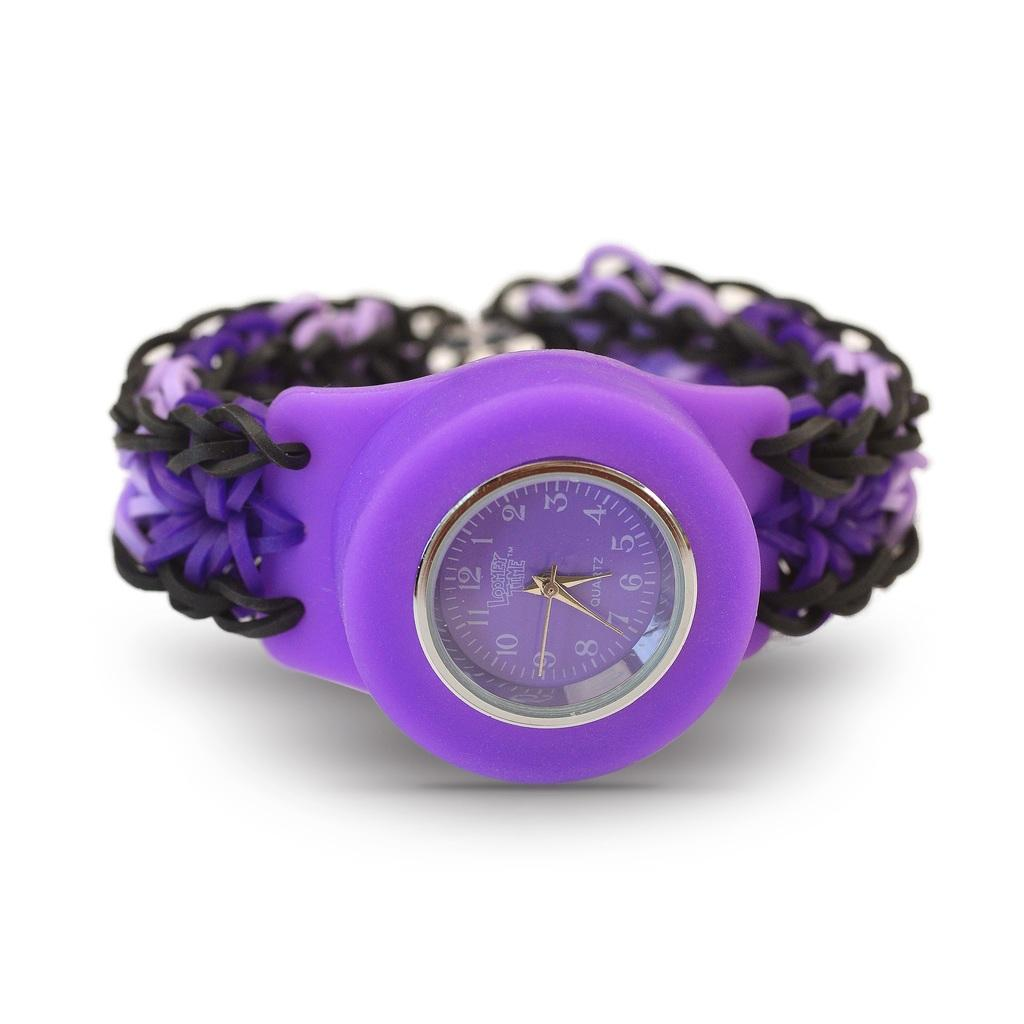Provide a one-sentence caption for the provided image. A purple Loomy Time quartz wristwatch with a comfortable stretchy band. 